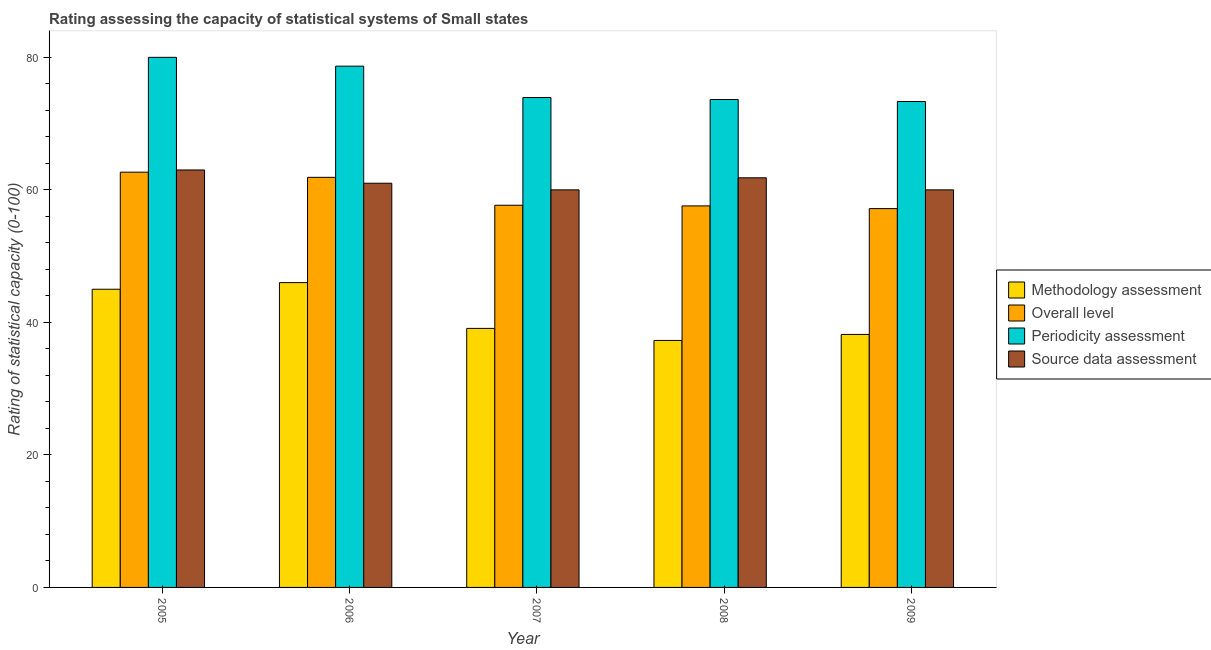How many different coloured bars are there?
Ensure brevity in your answer.  4. How many bars are there on the 5th tick from the right?
Your answer should be very brief. 4. In how many cases, is the number of bars for a given year not equal to the number of legend labels?
Make the answer very short. 0. What is the methodology assessment rating in 2005?
Give a very brief answer. 45. Across all years, what is the maximum periodicity assessment rating?
Keep it short and to the point. 80. Across all years, what is the minimum periodicity assessment rating?
Provide a short and direct response. 73.33. What is the total overall level rating in the graph?
Your response must be concise. 296.98. What is the difference between the source data assessment rating in 2006 and that in 2008?
Your answer should be compact. -0.82. What is the difference between the methodology assessment rating in 2005 and the overall level rating in 2009?
Offer a very short reply. 6.82. What is the average source data assessment rating per year?
Make the answer very short. 61.16. In the year 2007, what is the difference between the source data assessment rating and periodicity assessment rating?
Keep it short and to the point. 0. What is the ratio of the overall level rating in 2005 to that in 2007?
Your answer should be compact. 1.09. What is the difference between the highest and the second highest overall level rating?
Make the answer very short. 0.78. What is the difference between the highest and the lowest periodicity assessment rating?
Give a very brief answer. 6.67. In how many years, is the periodicity assessment rating greater than the average periodicity assessment rating taken over all years?
Provide a succinct answer. 2. Is the sum of the methodology assessment rating in 2007 and 2008 greater than the maximum periodicity assessment rating across all years?
Keep it short and to the point. Yes. What does the 4th bar from the left in 2005 represents?
Your answer should be very brief. Source data assessment. What does the 2nd bar from the right in 2008 represents?
Your answer should be very brief. Periodicity assessment. Is it the case that in every year, the sum of the methodology assessment rating and overall level rating is greater than the periodicity assessment rating?
Make the answer very short. Yes. How many bars are there?
Provide a succinct answer. 20. Are all the bars in the graph horizontal?
Provide a succinct answer. No. How many years are there in the graph?
Provide a short and direct response. 5. What is the difference between two consecutive major ticks on the Y-axis?
Offer a terse response. 20. Are the values on the major ticks of Y-axis written in scientific E-notation?
Provide a short and direct response. No. Does the graph contain any zero values?
Your answer should be compact. No. Where does the legend appear in the graph?
Provide a short and direct response. Center right. How are the legend labels stacked?
Make the answer very short. Vertical. What is the title of the graph?
Make the answer very short. Rating assessing the capacity of statistical systems of Small states. What is the label or title of the X-axis?
Your answer should be compact. Year. What is the label or title of the Y-axis?
Your answer should be very brief. Rating of statistical capacity (0-100). What is the Rating of statistical capacity (0-100) of Methodology assessment in 2005?
Ensure brevity in your answer.  45. What is the Rating of statistical capacity (0-100) of Overall level in 2005?
Provide a succinct answer. 62.67. What is the Rating of statistical capacity (0-100) of Periodicity assessment in 2005?
Your answer should be very brief. 80. What is the Rating of statistical capacity (0-100) in Source data assessment in 2005?
Your response must be concise. 63. What is the Rating of statistical capacity (0-100) of Methodology assessment in 2006?
Provide a short and direct response. 46. What is the Rating of statistical capacity (0-100) of Overall level in 2006?
Make the answer very short. 61.89. What is the Rating of statistical capacity (0-100) in Periodicity assessment in 2006?
Ensure brevity in your answer.  78.67. What is the Rating of statistical capacity (0-100) of Source data assessment in 2006?
Keep it short and to the point. 61. What is the Rating of statistical capacity (0-100) in Methodology assessment in 2007?
Provide a short and direct response. 39.09. What is the Rating of statistical capacity (0-100) of Overall level in 2007?
Your response must be concise. 57.68. What is the Rating of statistical capacity (0-100) in Periodicity assessment in 2007?
Your response must be concise. 73.94. What is the Rating of statistical capacity (0-100) of Methodology assessment in 2008?
Provide a short and direct response. 37.27. What is the Rating of statistical capacity (0-100) of Overall level in 2008?
Keep it short and to the point. 57.58. What is the Rating of statistical capacity (0-100) of Periodicity assessment in 2008?
Make the answer very short. 73.64. What is the Rating of statistical capacity (0-100) in Source data assessment in 2008?
Give a very brief answer. 61.82. What is the Rating of statistical capacity (0-100) of Methodology assessment in 2009?
Offer a terse response. 38.18. What is the Rating of statistical capacity (0-100) in Overall level in 2009?
Give a very brief answer. 57.17. What is the Rating of statistical capacity (0-100) in Periodicity assessment in 2009?
Give a very brief answer. 73.33. Across all years, what is the maximum Rating of statistical capacity (0-100) in Methodology assessment?
Make the answer very short. 46. Across all years, what is the maximum Rating of statistical capacity (0-100) of Overall level?
Your answer should be very brief. 62.67. Across all years, what is the maximum Rating of statistical capacity (0-100) of Periodicity assessment?
Make the answer very short. 80. Across all years, what is the maximum Rating of statistical capacity (0-100) in Source data assessment?
Keep it short and to the point. 63. Across all years, what is the minimum Rating of statistical capacity (0-100) in Methodology assessment?
Offer a very short reply. 37.27. Across all years, what is the minimum Rating of statistical capacity (0-100) in Overall level?
Give a very brief answer. 57.17. Across all years, what is the minimum Rating of statistical capacity (0-100) of Periodicity assessment?
Make the answer very short. 73.33. What is the total Rating of statistical capacity (0-100) of Methodology assessment in the graph?
Your response must be concise. 205.55. What is the total Rating of statistical capacity (0-100) in Overall level in the graph?
Your response must be concise. 296.98. What is the total Rating of statistical capacity (0-100) of Periodicity assessment in the graph?
Your answer should be compact. 379.58. What is the total Rating of statistical capacity (0-100) in Source data assessment in the graph?
Ensure brevity in your answer.  305.82. What is the difference between the Rating of statistical capacity (0-100) in Methodology assessment in 2005 and that in 2006?
Ensure brevity in your answer.  -1. What is the difference between the Rating of statistical capacity (0-100) in Methodology assessment in 2005 and that in 2007?
Provide a short and direct response. 5.91. What is the difference between the Rating of statistical capacity (0-100) of Overall level in 2005 and that in 2007?
Offer a terse response. 4.99. What is the difference between the Rating of statistical capacity (0-100) in Periodicity assessment in 2005 and that in 2007?
Provide a succinct answer. 6.06. What is the difference between the Rating of statistical capacity (0-100) in Methodology assessment in 2005 and that in 2008?
Offer a terse response. 7.73. What is the difference between the Rating of statistical capacity (0-100) of Overall level in 2005 and that in 2008?
Keep it short and to the point. 5.09. What is the difference between the Rating of statistical capacity (0-100) of Periodicity assessment in 2005 and that in 2008?
Your response must be concise. 6.36. What is the difference between the Rating of statistical capacity (0-100) of Source data assessment in 2005 and that in 2008?
Offer a very short reply. 1.18. What is the difference between the Rating of statistical capacity (0-100) in Methodology assessment in 2005 and that in 2009?
Make the answer very short. 6.82. What is the difference between the Rating of statistical capacity (0-100) of Overall level in 2005 and that in 2009?
Your answer should be very brief. 5.49. What is the difference between the Rating of statistical capacity (0-100) in Periodicity assessment in 2005 and that in 2009?
Ensure brevity in your answer.  6.67. What is the difference between the Rating of statistical capacity (0-100) of Source data assessment in 2005 and that in 2009?
Ensure brevity in your answer.  3. What is the difference between the Rating of statistical capacity (0-100) of Methodology assessment in 2006 and that in 2007?
Offer a very short reply. 6.91. What is the difference between the Rating of statistical capacity (0-100) of Overall level in 2006 and that in 2007?
Give a very brief answer. 4.21. What is the difference between the Rating of statistical capacity (0-100) in Periodicity assessment in 2006 and that in 2007?
Keep it short and to the point. 4.73. What is the difference between the Rating of statistical capacity (0-100) in Source data assessment in 2006 and that in 2007?
Your answer should be compact. 1. What is the difference between the Rating of statistical capacity (0-100) of Methodology assessment in 2006 and that in 2008?
Your answer should be compact. 8.73. What is the difference between the Rating of statistical capacity (0-100) in Overall level in 2006 and that in 2008?
Provide a short and direct response. 4.31. What is the difference between the Rating of statistical capacity (0-100) of Periodicity assessment in 2006 and that in 2008?
Provide a short and direct response. 5.03. What is the difference between the Rating of statistical capacity (0-100) in Source data assessment in 2006 and that in 2008?
Offer a terse response. -0.82. What is the difference between the Rating of statistical capacity (0-100) in Methodology assessment in 2006 and that in 2009?
Your answer should be compact. 7.82. What is the difference between the Rating of statistical capacity (0-100) of Overall level in 2006 and that in 2009?
Offer a terse response. 4.72. What is the difference between the Rating of statistical capacity (0-100) in Periodicity assessment in 2006 and that in 2009?
Keep it short and to the point. 5.33. What is the difference between the Rating of statistical capacity (0-100) of Source data assessment in 2006 and that in 2009?
Your response must be concise. 1. What is the difference between the Rating of statistical capacity (0-100) of Methodology assessment in 2007 and that in 2008?
Your answer should be very brief. 1.82. What is the difference between the Rating of statistical capacity (0-100) in Overall level in 2007 and that in 2008?
Keep it short and to the point. 0.1. What is the difference between the Rating of statistical capacity (0-100) in Periodicity assessment in 2007 and that in 2008?
Your answer should be compact. 0.3. What is the difference between the Rating of statistical capacity (0-100) in Source data assessment in 2007 and that in 2008?
Offer a terse response. -1.82. What is the difference between the Rating of statistical capacity (0-100) of Methodology assessment in 2007 and that in 2009?
Offer a very short reply. 0.91. What is the difference between the Rating of statistical capacity (0-100) in Overall level in 2007 and that in 2009?
Your answer should be very brief. 0.51. What is the difference between the Rating of statistical capacity (0-100) in Periodicity assessment in 2007 and that in 2009?
Your answer should be very brief. 0.61. What is the difference between the Rating of statistical capacity (0-100) in Methodology assessment in 2008 and that in 2009?
Your answer should be compact. -0.91. What is the difference between the Rating of statistical capacity (0-100) in Overall level in 2008 and that in 2009?
Provide a short and direct response. 0.4. What is the difference between the Rating of statistical capacity (0-100) in Periodicity assessment in 2008 and that in 2009?
Give a very brief answer. 0.3. What is the difference between the Rating of statistical capacity (0-100) of Source data assessment in 2008 and that in 2009?
Ensure brevity in your answer.  1.82. What is the difference between the Rating of statistical capacity (0-100) of Methodology assessment in 2005 and the Rating of statistical capacity (0-100) of Overall level in 2006?
Keep it short and to the point. -16.89. What is the difference between the Rating of statistical capacity (0-100) of Methodology assessment in 2005 and the Rating of statistical capacity (0-100) of Periodicity assessment in 2006?
Your answer should be compact. -33.67. What is the difference between the Rating of statistical capacity (0-100) of Methodology assessment in 2005 and the Rating of statistical capacity (0-100) of Source data assessment in 2006?
Ensure brevity in your answer.  -16. What is the difference between the Rating of statistical capacity (0-100) of Methodology assessment in 2005 and the Rating of statistical capacity (0-100) of Overall level in 2007?
Give a very brief answer. -12.68. What is the difference between the Rating of statistical capacity (0-100) of Methodology assessment in 2005 and the Rating of statistical capacity (0-100) of Periodicity assessment in 2007?
Your answer should be compact. -28.94. What is the difference between the Rating of statistical capacity (0-100) in Methodology assessment in 2005 and the Rating of statistical capacity (0-100) in Source data assessment in 2007?
Offer a very short reply. -15. What is the difference between the Rating of statistical capacity (0-100) of Overall level in 2005 and the Rating of statistical capacity (0-100) of Periodicity assessment in 2007?
Offer a very short reply. -11.27. What is the difference between the Rating of statistical capacity (0-100) in Overall level in 2005 and the Rating of statistical capacity (0-100) in Source data assessment in 2007?
Your answer should be compact. 2.67. What is the difference between the Rating of statistical capacity (0-100) of Methodology assessment in 2005 and the Rating of statistical capacity (0-100) of Overall level in 2008?
Offer a terse response. -12.58. What is the difference between the Rating of statistical capacity (0-100) of Methodology assessment in 2005 and the Rating of statistical capacity (0-100) of Periodicity assessment in 2008?
Keep it short and to the point. -28.64. What is the difference between the Rating of statistical capacity (0-100) in Methodology assessment in 2005 and the Rating of statistical capacity (0-100) in Source data assessment in 2008?
Offer a very short reply. -16.82. What is the difference between the Rating of statistical capacity (0-100) in Overall level in 2005 and the Rating of statistical capacity (0-100) in Periodicity assessment in 2008?
Give a very brief answer. -10.97. What is the difference between the Rating of statistical capacity (0-100) of Overall level in 2005 and the Rating of statistical capacity (0-100) of Source data assessment in 2008?
Ensure brevity in your answer.  0.85. What is the difference between the Rating of statistical capacity (0-100) in Periodicity assessment in 2005 and the Rating of statistical capacity (0-100) in Source data assessment in 2008?
Your answer should be compact. 18.18. What is the difference between the Rating of statistical capacity (0-100) in Methodology assessment in 2005 and the Rating of statistical capacity (0-100) in Overall level in 2009?
Ensure brevity in your answer.  -12.17. What is the difference between the Rating of statistical capacity (0-100) of Methodology assessment in 2005 and the Rating of statistical capacity (0-100) of Periodicity assessment in 2009?
Your response must be concise. -28.33. What is the difference between the Rating of statistical capacity (0-100) of Overall level in 2005 and the Rating of statistical capacity (0-100) of Periodicity assessment in 2009?
Your answer should be very brief. -10.67. What is the difference between the Rating of statistical capacity (0-100) of Overall level in 2005 and the Rating of statistical capacity (0-100) of Source data assessment in 2009?
Give a very brief answer. 2.67. What is the difference between the Rating of statistical capacity (0-100) of Methodology assessment in 2006 and the Rating of statistical capacity (0-100) of Overall level in 2007?
Provide a succinct answer. -11.68. What is the difference between the Rating of statistical capacity (0-100) in Methodology assessment in 2006 and the Rating of statistical capacity (0-100) in Periodicity assessment in 2007?
Give a very brief answer. -27.94. What is the difference between the Rating of statistical capacity (0-100) of Methodology assessment in 2006 and the Rating of statistical capacity (0-100) of Source data assessment in 2007?
Give a very brief answer. -14. What is the difference between the Rating of statistical capacity (0-100) in Overall level in 2006 and the Rating of statistical capacity (0-100) in Periodicity assessment in 2007?
Your answer should be compact. -12.05. What is the difference between the Rating of statistical capacity (0-100) of Overall level in 2006 and the Rating of statistical capacity (0-100) of Source data assessment in 2007?
Give a very brief answer. 1.89. What is the difference between the Rating of statistical capacity (0-100) in Periodicity assessment in 2006 and the Rating of statistical capacity (0-100) in Source data assessment in 2007?
Ensure brevity in your answer.  18.67. What is the difference between the Rating of statistical capacity (0-100) in Methodology assessment in 2006 and the Rating of statistical capacity (0-100) in Overall level in 2008?
Keep it short and to the point. -11.58. What is the difference between the Rating of statistical capacity (0-100) of Methodology assessment in 2006 and the Rating of statistical capacity (0-100) of Periodicity assessment in 2008?
Provide a short and direct response. -27.64. What is the difference between the Rating of statistical capacity (0-100) of Methodology assessment in 2006 and the Rating of statistical capacity (0-100) of Source data assessment in 2008?
Offer a terse response. -15.82. What is the difference between the Rating of statistical capacity (0-100) of Overall level in 2006 and the Rating of statistical capacity (0-100) of Periodicity assessment in 2008?
Keep it short and to the point. -11.75. What is the difference between the Rating of statistical capacity (0-100) of Overall level in 2006 and the Rating of statistical capacity (0-100) of Source data assessment in 2008?
Provide a short and direct response. 0.07. What is the difference between the Rating of statistical capacity (0-100) of Periodicity assessment in 2006 and the Rating of statistical capacity (0-100) of Source data assessment in 2008?
Your answer should be very brief. 16.85. What is the difference between the Rating of statistical capacity (0-100) of Methodology assessment in 2006 and the Rating of statistical capacity (0-100) of Overall level in 2009?
Your response must be concise. -11.17. What is the difference between the Rating of statistical capacity (0-100) of Methodology assessment in 2006 and the Rating of statistical capacity (0-100) of Periodicity assessment in 2009?
Make the answer very short. -27.33. What is the difference between the Rating of statistical capacity (0-100) of Methodology assessment in 2006 and the Rating of statistical capacity (0-100) of Source data assessment in 2009?
Your answer should be compact. -14. What is the difference between the Rating of statistical capacity (0-100) in Overall level in 2006 and the Rating of statistical capacity (0-100) in Periodicity assessment in 2009?
Provide a short and direct response. -11.44. What is the difference between the Rating of statistical capacity (0-100) of Overall level in 2006 and the Rating of statistical capacity (0-100) of Source data assessment in 2009?
Your response must be concise. 1.89. What is the difference between the Rating of statistical capacity (0-100) of Periodicity assessment in 2006 and the Rating of statistical capacity (0-100) of Source data assessment in 2009?
Your response must be concise. 18.67. What is the difference between the Rating of statistical capacity (0-100) in Methodology assessment in 2007 and the Rating of statistical capacity (0-100) in Overall level in 2008?
Give a very brief answer. -18.48. What is the difference between the Rating of statistical capacity (0-100) of Methodology assessment in 2007 and the Rating of statistical capacity (0-100) of Periodicity assessment in 2008?
Provide a short and direct response. -34.55. What is the difference between the Rating of statistical capacity (0-100) in Methodology assessment in 2007 and the Rating of statistical capacity (0-100) in Source data assessment in 2008?
Your answer should be very brief. -22.73. What is the difference between the Rating of statistical capacity (0-100) in Overall level in 2007 and the Rating of statistical capacity (0-100) in Periodicity assessment in 2008?
Ensure brevity in your answer.  -15.96. What is the difference between the Rating of statistical capacity (0-100) in Overall level in 2007 and the Rating of statistical capacity (0-100) in Source data assessment in 2008?
Your answer should be very brief. -4.14. What is the difference between the Rating of statistical capacity (0-100) in Periodicity assessment in 2007 and the Rating of statistical capacity (0-100) in Source data assessment in 2008?
Keep it short and to the point. 12.12. What is the difference between the Rating of statistical capacity (0-100) in Methodology assessment in 2007 and the Rating of statistical capacity (0-100) in Overall level in 2009?
Offer a terse response. -18.08. What is the difference between the Rating of statistical capacity (0-100) in Methodology assessment in 2007 and the Rating of statistical capacity (0-100) in Periodicity assessment in 2009?
Keep it short and to the point. -34.24. What is the difference between the Rating of statistical capacity (0-100) of Methodology assessment in 2007 and the Rating of statistical capacity (0-100) of Source data assessment in 2009?
Your answer should be very brief. -20.91. What is the difference between the Rating of statistical capacity (0-100) in Overall level in 2007 and the Rating of statistical capacity (0-100) in Periodicity assessment in 2009?
Provide a succinct answer. -15.66. What is the difference between the Rating of statistical capacity (0-100) of Overall level in 2007 and the Rating of statistical capacity (0-100) of Source data assessment in 2009?
Offer a very short reply. -2.32. What is the difference between the Rating of statistical capacity (0-100) in Periodicity assessment in 2007 and the Rating of statistical capacity (0-100) in Source data assessment in 2009?
Give a very brief answer. 13.94. What is the difference between the Rating of statistical capacity (0-100) of Methodology assessment in 2008 and the Rating of statistical capacity (0-100) of Overall level in 2009?
Provide a succinct answer. -19.9. What is the difference between the Rating of statistical capacity (0-100) in Methodology assessment in 2008 and the Rating of statistical capacity (0-100) in Periodicity assessment in 2009?
Make the answer very short. -36.06. What is the difference between the Rating of statistical capacity (0-100) of Methodology assessment in 2008 and the Rating of statistical capacity (0-100) of Source data assessment in 2009?
Your answer should be compact. -22.73. What is the difference between the Rating of statistical capacity (0-100) of Overall level in 2008 and the Rating of statistical capacity (0-100) of Periodicity assessment in 2009?
Your answer should be very brief. -15.76. What is the difference between the Rating of statistical capacity (0-100) of Overall level in 2008 and the Rating of statistical capacity (0-100) of Source data assessment in 2009?
Provide a short and direct response. -2.42. What is the difference between the Rating of statistical capacity (0-100) in Periodicity assessment in 2008 and the Rating of statistical capacity (0-100) in Source data assessment in 2009?
Your response must be concise. 13.64. What is the average Rating of statistical capacity (0-100) in Methodology assessment per year?
Your answer should be compact. 41.11. What is the average Rating of statistical capacity (0-100) of Overall level per year?
Give a very brief answer. 59.4. What is the average Rating of statistical capacity (0-100) of Periodicity assessment per year?
Your answer should be compact. 75.92. What is the average Rating of statistical capacity (0-100) of Source data assessment per year?
Offer a terse response. 61.16. In the year 2005, what is the difference between the Rating of statistical capacity (0-100) in Methodology assessment and Rating of statistical capacity (0-100) in Overall level?
Your response must be concise. -17.67. In the year 2005, what is the difference between the Rating of statistical capacity (0-100) of Methodology assessment and Rating of statistical capacity (0-100) of Periodicity assessment?
Offer a terse response. -35. In the year 2005, what is the difference between the Rating of statistical capacity (0-100) of Overall level and Rating of statistical capacity (0-100) of Periodicity assessment?
Offer a very short reply. -17.33. In the year 2005, what is the difference between the Rating of statistical capacity (0-100) in Overall level and Rating of statistical capacity (0-100) in Source data assessment?
Keep it short and to the point. -0.33. In the year 2006, what is the difference between the Rating of statistical capacity (0-100) of Methodology assessment and Rating of statistical capacity (0-100) of Overall level?
Provide a short and direct response. -15.89. In the year 2006, what is the difference between the Rating of statistical capacity (0-100) in Methodology assessment and Rating of statistical capacity (0-100) in Periodicity assessment?
Provide a succinct answer. -32.67. In the year 2006, what is the difference between the Rating of statistical capacity (0-100) of Overall level and Rating of statistical capacity (0-100) of Periodicity assessment?
Your answer should be very brief. -16.78. In the year 2006, what is the difference between the Rating of statistical capacity (0-100) of Overall level and Rating of statistical capacity (0-100) of Source data assessment?
Provide a succinct answer. 0.89. In the year 2006, what is the difference between the Rating of statistical capacity (0-100) in Periodicity assessment and Rating of statistical capacity (0-100) in Source data assessment?
Offer a very short reply. 17.67. In the year 2007, what is the difference between the Rating of statistical capacity (0-100) in Methodology assessment and Rating of statistical capacity (0-100) in Overall level?
Your answer should be compact. -18.59. In the year 2007, what is the difference between the Rating of statistical capacity (0-100) in Methodology assessment and Rating of statistical capacity (0-100) in Periodicity assessment?
Give a very brief answer. -34.85. In the year 2007, what is the difference between the Rating of statistical capacity (0-100) of Methodology assessment and Rating of statistical capacity (0-100) of Source data assessment?
Offer a very short reply. -20.91. In the year 2007, what is the difference between the Rating of statistical capacity (0-100) of Overall level and Rating of statistical capacity (0-100) of Periodicity assessment?
Your response must be concise. -16.26. In the year 2007, what is the difference between the Rating of statistical capacity (0-100) of Overall level and Rating of statistical capacity (0-100) of Source data assessment?
Provide a succinct answer. -2.32. In the year 2007, what is the difference between the Rating of statistical capacity (0-100) of Periodicity assessment and Rating of statistical capacity (0-100) of Source data assessment?
Your answer should be very brief. 13.94. In the year 2008, what is the difference between the Rating of statistical capacity (0-100) in Methodology assessment and Rating of statistical capacity (0-100) in Overall level?
Keep it short and to the point. -20.3. In the year 2008, what is the difference between the Rating of statistical capacity (0-100) of Methodology assessment and Rating of statistical capacity (0-100) of Periodicity assessment?
Your response must be concise. -36.36. In the year 2008, what is the difference between the Rating of statistical capacity (0-100) of Methodology assessment and Rating of statistical capacity (0-100) of Source data assessment?
Your answer should be very brief. -24.55. In the year 2008, what is the difference between the Rating of statistical capacity (0-100) of Overall level and Rating of statistical capacity (0-100) of Periodicity assessment?
Make the answer very short. -16.06. In the year 2008, what is the difference between the Rating of statistical capacity (0-100) of Overall level and Rating of statistical capacity (0-100) of Source data assessment?
Offer a very short reply. -4.24. In the year 2008, what is the difference between the Rating of statistical capacity (0-100) of Periodicity assessment and Rating of statistical capacity (0-100) of Source data assessment?
Offer a terse response. 11.82. In the year 2009, what is the difference between the Rating of statistical capacity (0-100) in Methodology assessment and Rating of statistical capacity (0-100) in Overall level?
Ensure brevity in your answer.  -18.99. In the year 2009, what is the difference between the Rating of statistical capacity (0-100) in Methodology assessment and Rating of statistical capacity (0-100) in Periodicity assessment?
Keep it short and to the point. -35.15. In the year 2009, what is the difference between the Rating of statistical capacity (0-100) in Methodology assessment and Rating of statistical capacity (0-100) in Source data assessment?
Your answer should be very brief. -21.82. In the year 2009, what is the difference between the Rating of statistical capacity (0-100) in Overall level and Rating of statistical capacity (0-100) in Periodicity assessment?
Your response must be concise. -16.16. In the year 2009, what is the difference between the Rating of statistical capacity (0-100) of Overall level and Rating of statistical capacity (0-100) of Source data assessment?
Offer a terse response. -2.83. In the year 2009, what is the difference between the Rating of statistical capacity (0-100) in Periodicity assessment and Rating of statistical capacity (0-100) in Source data assessment?
Your answer should be very brief. 13.33. What is the ratio of the Rating of statistical capacity (0-100) of Methodology assessment in 2005 to that in 2006?
Ensure brevity in your answer.  0.98. What is the ratio of the Rating of statistical capacity (0-100) in Overall level in 2005 to that in 2006?
Offer a terse response. 1.01. What is the ratio of the Rating of statistical capacity (0-100) in Periodicity assessment in 2005 to that in 2006?
Offer a terse response. 1.02. What is the ratio of the Rating of statistical capacity (0-100) of Source data assessment in 2005 to that in 2006?
Your answer should be compact. 1.03. What is the ratio of the Rating of statistical capacity (0-100) in Methodology assessment in 2005 to that in 2007?
Your response must be concise. 1.15. What is the ratio of the Rating of statistical capacity (0-100) in Overall level in 2005 to that in 2007?
Make the answer very short. 1.09. What is the ratio of the Rating of statistical capacity (0-100) in Periodicity assessment in 2005 to that in 2007?
Make the answer very short. 1.08. What is the ratio of the Rating of statistical capacity (0-100) of Source data assessment in 2005 to that in 2007?
Offer a terse response. 1.05. What is the ratio of the Rating of statistical capacity (0-100) of Methodology assessment in 2005 to that in 2008?
Offer a terse response. 1.21. What is the ratio of the Rating of statistical capacity (0-100) of Overall level in 2005 to that in 2008?
Keep it short and to the point. 1.09. What is the ratio of the Rating of statistical capacity (0-100) in Periodicity assessment in 2005 to that in 2008?
Give a very brief answer. 1.09. What is the ratio of the Rating of statistical capacity (0-100) in Source data assessment in 2005 to that in 2008?
Offer a very short reply. 1.02. What is the ratio of the Rating of statistical capacity (0-100) of Methodology assessment in 2005 to that in 2009?
Offer a terse response. 1.18. What is the ratio of the Rating of statistical capacity (0-100) of Overall level in 2005 to that in 2009?
Provide a succinct answer. 1.1. What is the ratio of the Rating of statistical capacity (0-100) of Methodology assessment in 2006 to that in 2007?
Your answer should be very brief. 1.18. What is the ratio of the Rating of statistical capacity (0-100) in Overall level in 2006 to that in 2007?
Offer a terse response. 1.07. What is the ratio of the Rating of statistical capacity (0-100) of Periodicity assessment in 2006 to that in 2007?
Give a very brief answer. 1.06. What is the ratio of the Rating of statistical capacity (0-100) in Source data assessment in 2006 to that in 2007?
Make the answer very short. 1.02. What is the ratio of the Rating of statistical capacity (0-100) in Methodology assessment in 2006 to that in 2008?
Provide a succinct answer. 1.23. What is the ratio of the Rating of statistical capacity (0-100) in Overall level in 2006 to that in 2008?
Provide a succinct answer. 1.07. What is the ratio of the Rating of statistical capacity (0-100) in Periodicity assessment in 2006 to that in 2008?
Provide a short and direct response. 1.07. What is the ratio of the Rating of statistical capacity (0-100) in Source data assessment in 2006 to that in 2008?
Provide a succinct answer. 0.99. What is the ratio of the Rating of statistical capacity (0-100) of Methodology assessment in 2006 to that in 2009?
Make the answer very short. 1.2. What is the ratio of the Rating of statistical capacity (0-100) of Overall level in 2006 to that in 2009?
Your answer should be very brief. 1.08. What is the ratio of the Rating of statistical capacity (0-100) of Periodicity assessment in 2006 to that in 2009?
Make the answer very short. 1.07. What is the ratio of the Rating of statistical capacity (0-100) of Source data assessment in 2006 to that in 2009?
Provide a short and direct response. 1.02. What is the ratio of the Rating of statistical capacity (0-100) in Methodology assessment in 2007 to that in 2008?
Your answer should be very brief. 1.05. What is the ratio of the Rating of statistical capacity (0-100) in Overall level in 2007 to that in 2008?
Keep it short and to the point. 1. What is the ratio of the Rating of statistical capacity (0-100) in Source data assessment in 2007 to that in 2008?
Provide a succinct answer. 0.97. What is the ratio of the Rating of statistical capacity (0-100) of Methodology assessment in 2007 to that in 2009?
Offer a very short reply. 1.02. What is the ratio of the Rating of statistical capacity (0-100) of Overall level in 2007 to that in 2009?
Give a very brief answer. 1.01. What is the ratio of the Rating of statistical capacity (0-100) in Periodicity assessment in 2007 to that in 2009?
Make the answer very short. 1.01. What is the ratio of the Rating of statistical capacity (0-100) of Methodology assessment in 2008 to that in 2009?
Make the answer very short. 0.98. What is the ratio of the Rating of statistical capacity (0-100) in Overall level in 2008 to that in 2009?
Your answer should be very brief. 1.01. What is the ratio of the Rating of statistical capacity (0-100) of Source data assessment in 2008 to that in 2009?
Your answer should be very brief. 1.03. What is the difference between the highest and the second highest Rating of statistical capacity (0-100) in Methodology assessment?
Ensure brevity in your answer.  1. What is the difference between the highest and the second highest Rating of statistical capacity (0-100) in Periodicity assessment?
Give a very brief answer. 1.33. What is the difference between the highest and the second highest Rating of statistical capacity (0-100) of Source data assessment?
Ensure brevity in your answer.  1.18. What is the difference between the highest and the lowest Rating of statistical capacity (0-100) in Methodology assessment?
Offer a terse response. 8.73. What is the difference between the highest and the lowest Rating of statistical capacity (0-100) in Overall level?
Make the answer very short. 5.49. What is the difference between the highest and the lowest Rating of statistical capacity (0-100) in Periodicity assessment?
Ensure brevity in your answer.  6.67. What is the difference between the highest and the lowest Rating of statistical capacity (0-100) of Source data assessment?
Offer a very short reply. 3. 